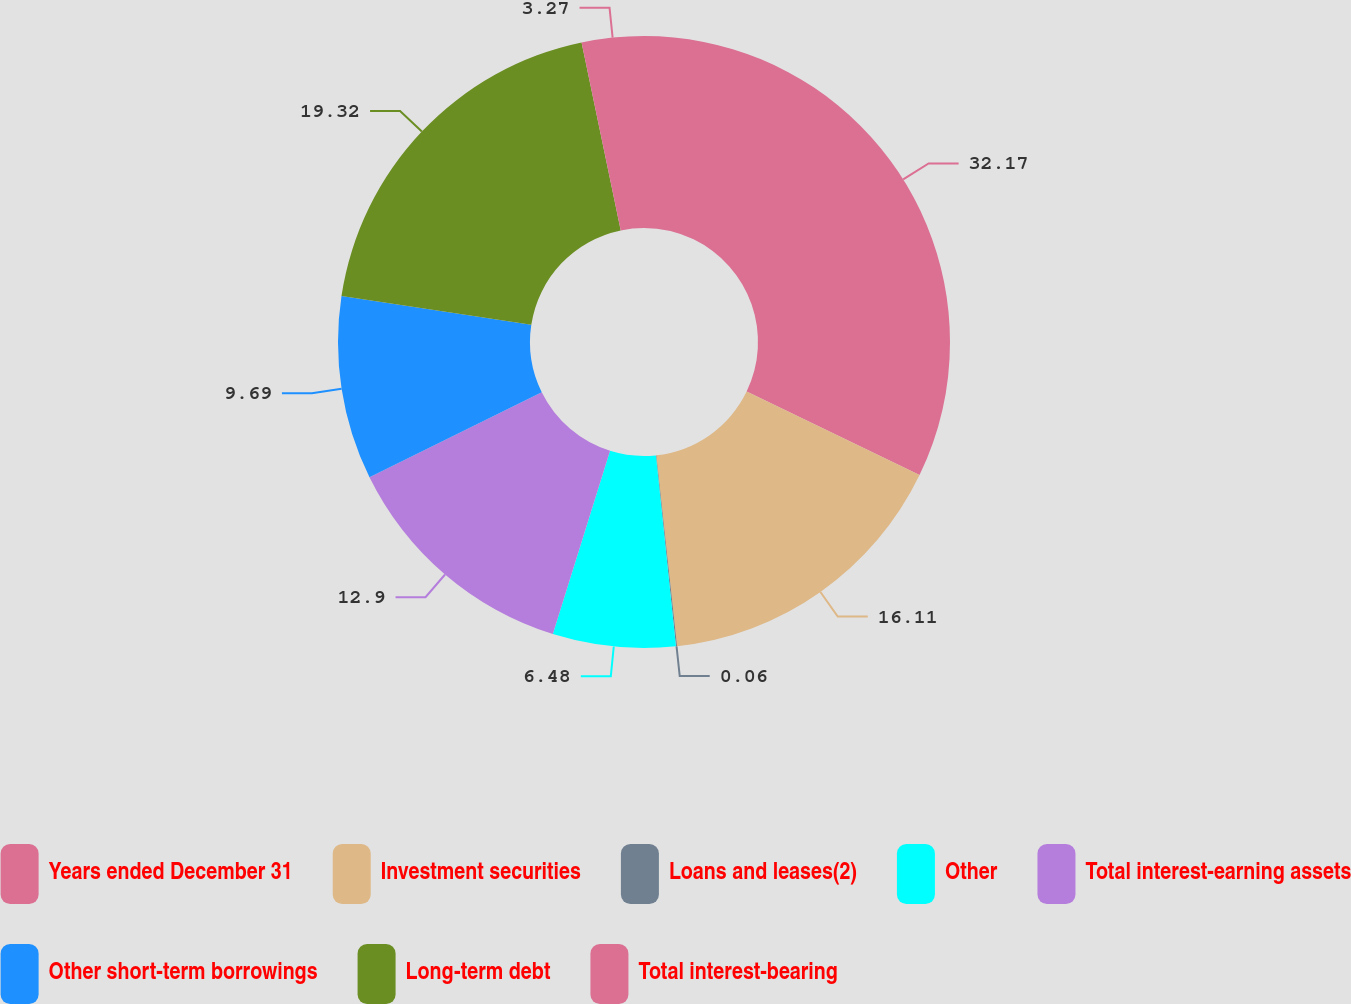Convert chart to OTSL. <chart><loc_0><loc_0><loc_500><loc_500><pie_chart><fcel>Years ended December 31<fcel>Investment securities<fcel>Loans and leases(2)<fcel>Other<fcel>Total interest-earning assets<fcel>Other short-term borrowings<fcel>Long-term debt<fcel>Total interest-bearing<nl><fcel>32.16%<fcel>16.11%<fcel>0.06%<fcel>6.48%<fcel>12.9%<fcel>9.69%<fcel>19.32%<fcel>3.27%<nl></chart> 